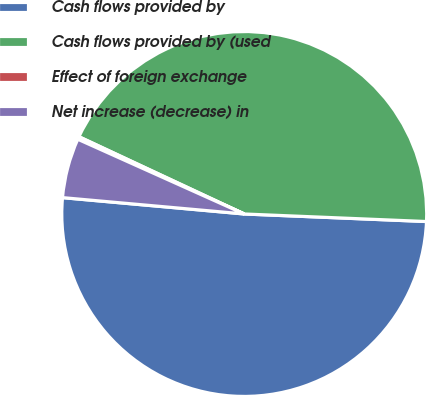Convert chart. <chart><loc_0><loc_0><loc_500><loc_500><pie_chart><fcel>Cash flows provided by<fcel>Cash flows provided by (used<fcel>Effect of foreign exchange<fcel>Net increase (decrease) in<nl><fcel>50.77%<fcel>43.7%<fcel>0.24%<fcel>5.29%<nl></chart> 